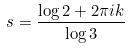<formula> <loc_0><loc_0><loc_500><loc_500>s = \frac { \log 2 + 2 \pi i k } { \log 3 }</formula> 